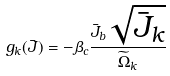Convert formula to latex. <formula><loc_0><loc_0><loc_500><loc_500>g _ { k } ( { \bar { J } } ) = - \beta _ { c } \frac { \bar { J } _ { b } \sqrt { \bar { J } _ { k } } } { \widetilde { \Omega } _ { k } }</formula> 